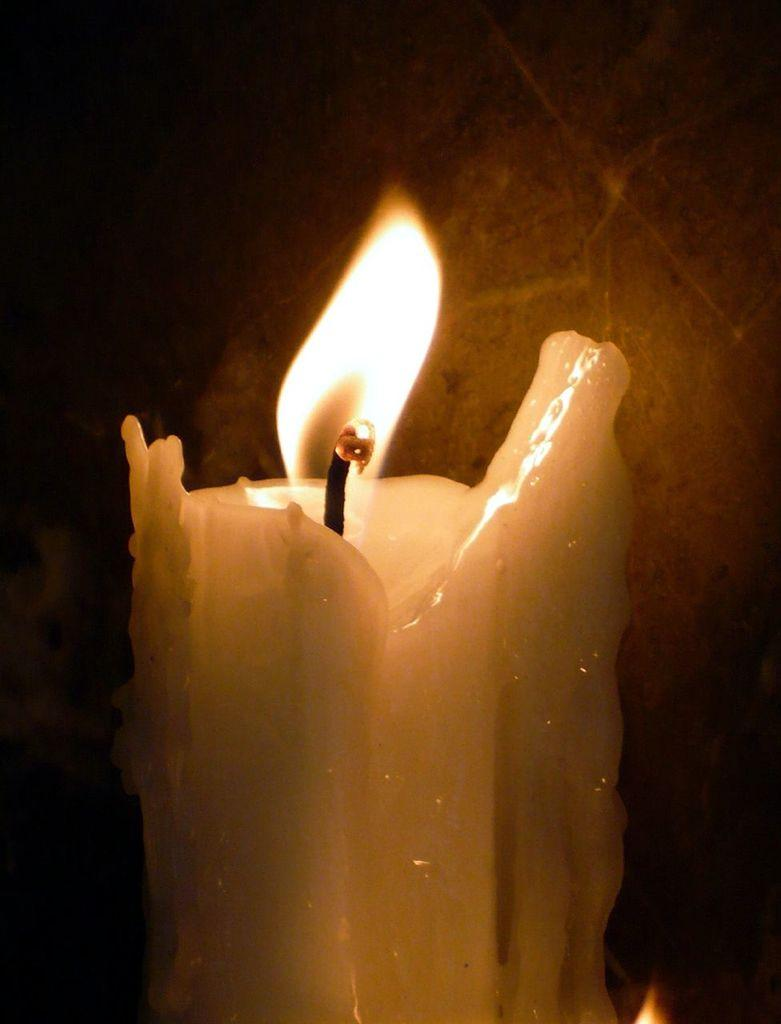What is the main object in the center of the image? There is a burning candle in the center of the image. What is the state of the candle in the image? The candle is burning in the image. What type of marble is used to decorate the birthday cake in the image? There is no birthday cake or marble present in the image; it only features a burning candle. 